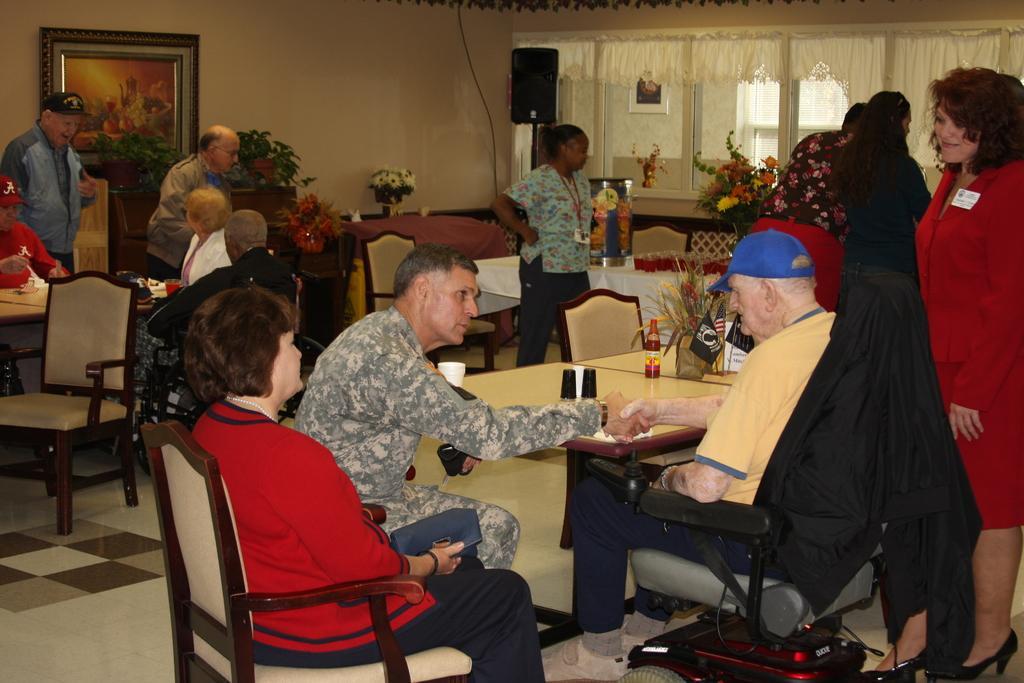Please provide a concise description of this image. In this image we can see these people are sitting in the chairs around the table. There are flower vases placed on each of the table. There is a photo frame on the wall. This is a speaker box and these are the curtains. 